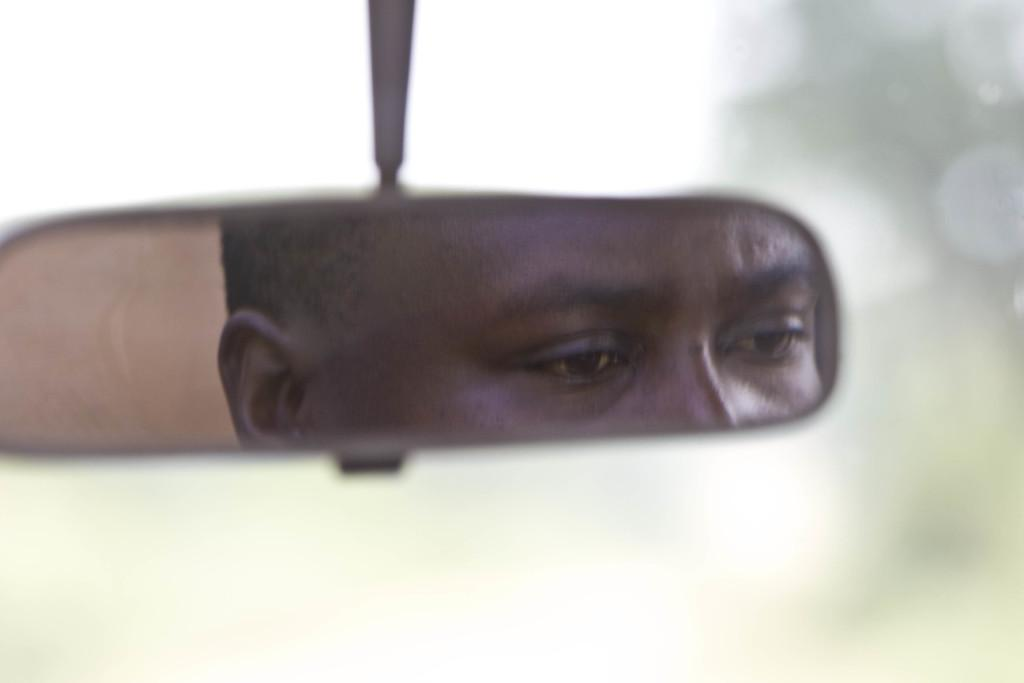What is visible in the mirror in the image? There is a reflection of a person on a mirror in the image. Can you describe the background of the image? The background of the image is blurred. Where is the deer located in the image? There is no deer present in the image. What type of jelly can be seen in the image? There is no jelly present in the image. Who is the creator of the image? The creator of the image is not mentioned in the provided facts. 